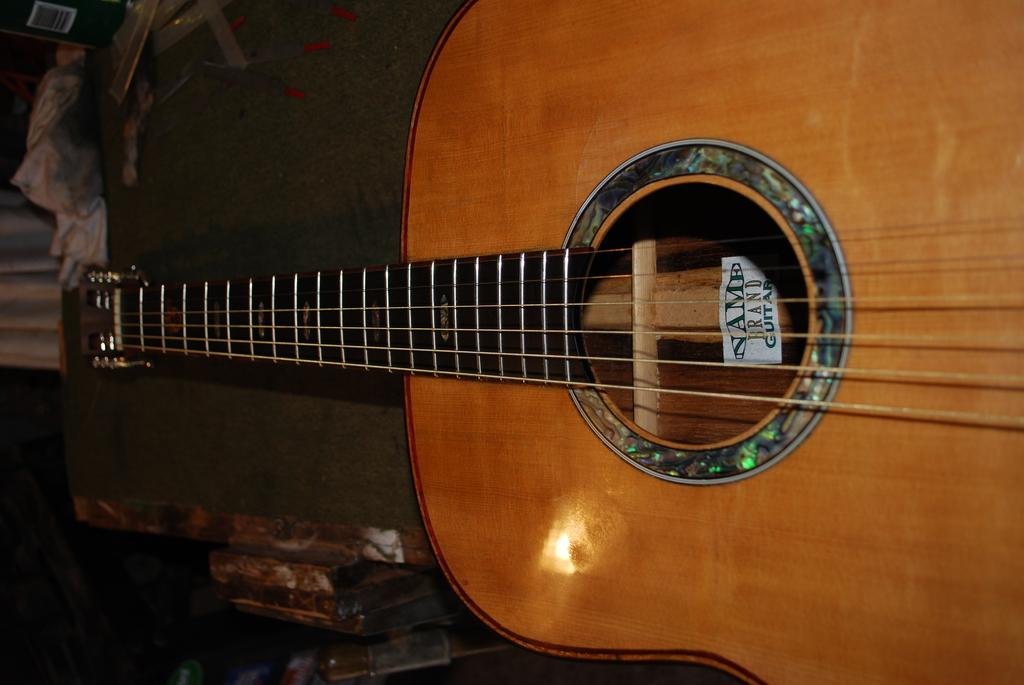What type of musical instrument is in the image? There is a brown color guitar in the image. What feature of the guitar is mentioned in the facts? The guitar has strings. What else can be seen in the image besides the guitar? There is a cloth visible in the image. How would you describe the overall appearance of the image? The image has a dark background or lighting. What reason does the guitar have for being in the image? The guitar does not have a reason for being in the image; it is simply a subject present in the photograph. How many things are present in the image? The number of things in the image cannot be determined from the provided facts, as only the guitar and cloth are mentioned. 